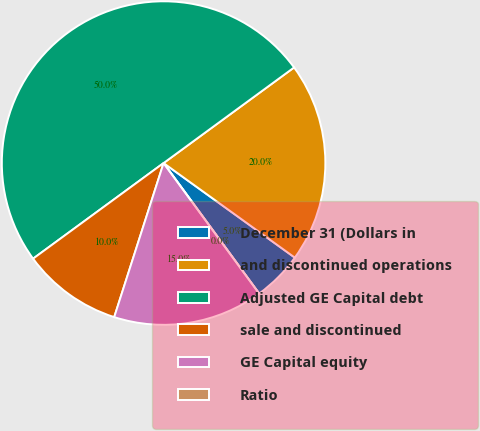Convert chart to OTSL. <chart><loc_0><loc_0><loc_500><loc_500><pie_chart><fcel>December 31 (Dollars in<fcel>and discontinued operations<fcel>Adjusted GE Capital debt<fcel>sale and discontinued<fcel>GE Capital equity<fcel>Ratio<nl><fcel>5.0%<fcel>20.0%<fcel>50.0%<fcel>10.0%<fcel>15.0%<fcel>0.0%<nl></chart> 